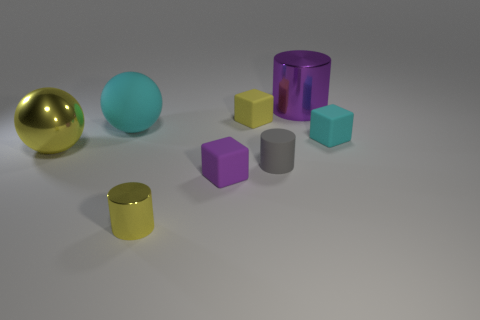Subtract all yellow cylinders. How many cylinders are left? 2 Subtract all cyan balls. How many balls are left? 1 Subtract 1 cylinders. How many cylinders are left? 2 Add 2 brown matte balls. How many objects exist? 10 Subtract 1 purple cylinders. How many objects are left? 7 Subtract all spheres. How many objects are left? 6 Subtract all yellow balls. Subtract all gray cylinders. How many balls are left? 1 Subtract all brown balls. How many red blocks are left? 0 Subtract all tiny purple matte things. Subtract all small yellow objects. How many objects are left? 5 Add 2 small purple things. How many small purple things are left? 3 